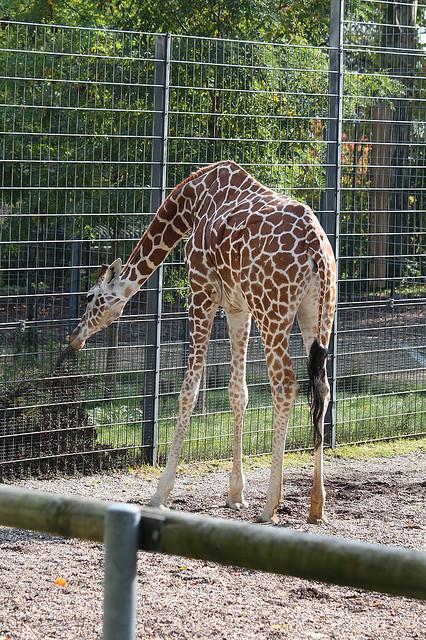Is the giraffe eating?
Be succinct. Yes. Is this a baby giraffe?
Write a very short answer. Yes. Do you see a large fence?
Answer briefly. Yes. Do you see a gate?
Give a very brief answer. No. 